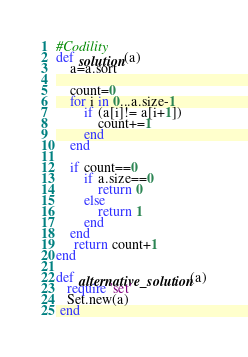Convert code to text. <code><loc_0><loc_0><loc_500><loc_500><_Ruby_>#Codility
def solution(a)
    a=a.sort
    
    count=0
    for i in 0...a.size-1
        if (a[i]!= a[i+1])
            count+=1
        end
    end
    
    if count==0
        if a.size==0
            return 0
        else
            return 1
        end
    end
     return count+1
end

def alternative_solution(a)
   require 'set' 
   Set.new(a) 
 end  
</code> 